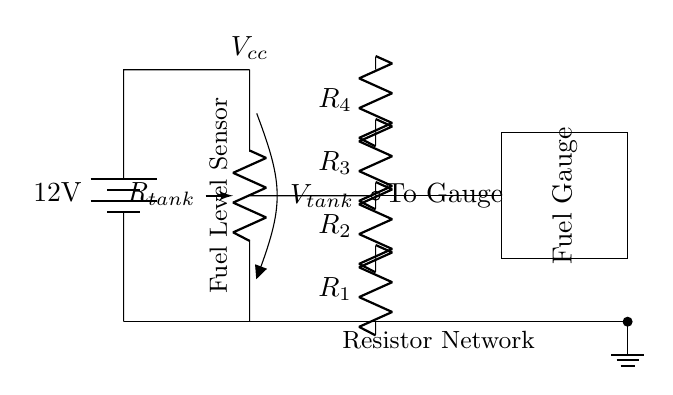What is the voltage source in this circuit? The circuit includes a 12V battery connected as the voltage source, which provides the necessary power for the rest of the circuit.
Answer: 12V What do the resistors R1 to R4 represent? R1 to R4 are part of the resistor network that likely helps to scale down the voltage coming from the fuel tank potentiometer to a level suitable for the gauge reading.
Answer: Resistor network What is the function of the potentiometer R_tank? The potentiometer R_tank serves as a fuel level sensor, adjusting its resistance based on the fuel level in the tank, which impacts the voltage supplied to the gauge.
Answer: Fuel level sensor How many resistors are present in the circuit? There are four resistors (R1, R2, R3, R4) in the network, each serving to regulate the voltage for the fuel gauge.
Answer: Four What connects the fuel tank potentiometer to the gauge? The connection from the potentiometer to the gauge is made with a short wire that carries the adjusted voltage from the fuel level sensor directly to the gauge.
Answer: Short wire What does the rectangle symbolize in this circuit? The rectangle symbolizes the fuel gauge, which displays the level of fuel in the tank based on the voltage it receives from the resistor network and the potentiometer.
Answer: Fuel gauge 